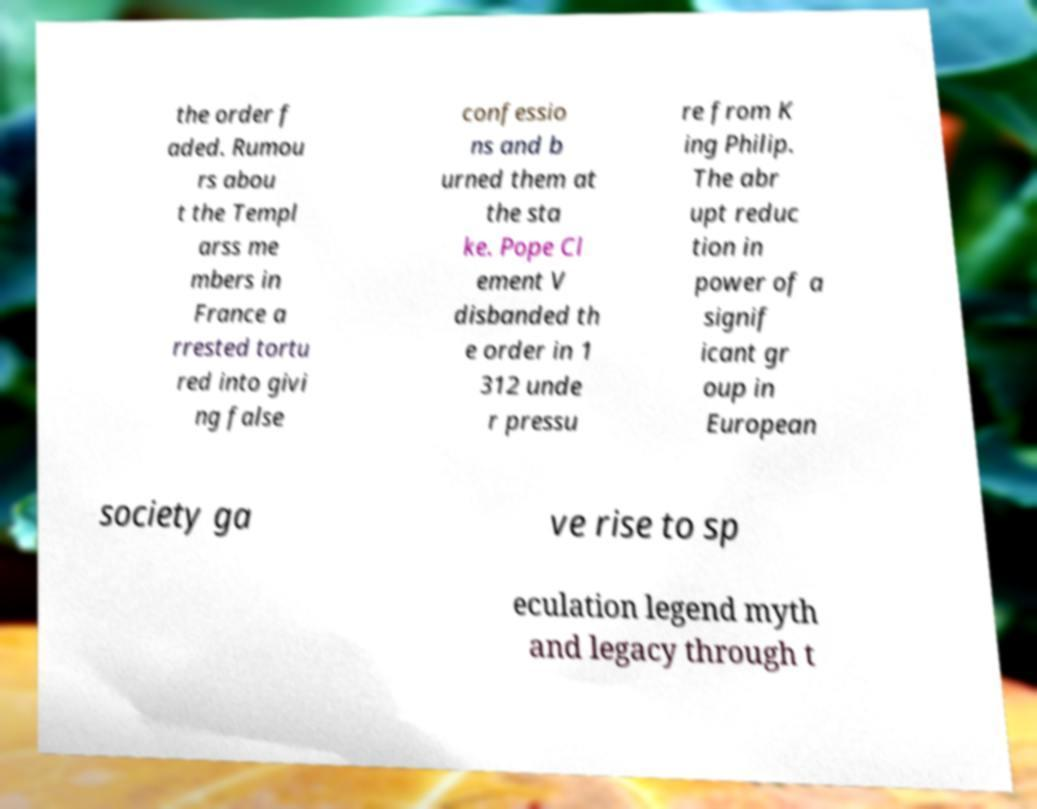What messages or text are displayed in this image? I need them in a readable, typed format. the order f aded. Rumou rs abou t the Templ arss me mbers in France a rrested tortu red into givi ng false confessio ns and b urned them at the sta ke. Pope Cl ement V disbanded th e order in 1 312 unde r pressu re from K ing Philip. The abr upt reduc tion in power of a signif icant gr oup in European society ga ve rise to sp eculation legend myth and legacy through t 